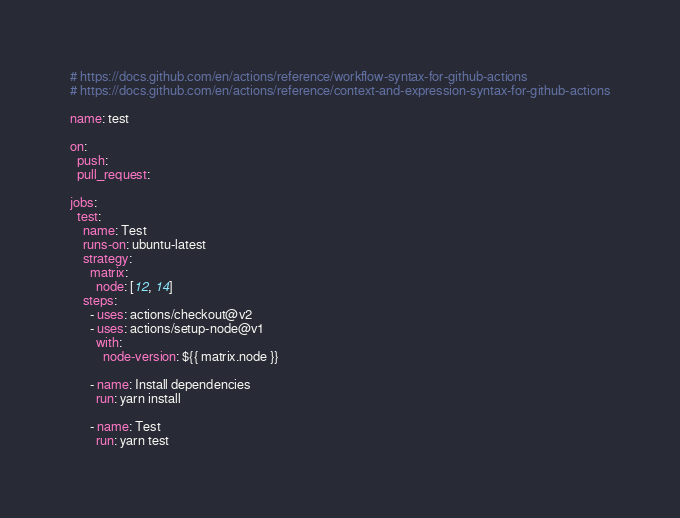Convert code to text. <code><loc_0><loc_0><loc_500><loc_500><_YAML_># https://docs.github.com/en/actions/reference/workflow-syntax-for-github-actions
# https://docs.github.com/en/actions/reference/context-and-expression-syntax-for-github-actions

name: test

on:
  push:
  pull_request:

jobs:
  test:
    name: Test
    runs-on: ubuntu-latest
    strategy:
      matrix:
        node: [12, 14]
    steps:
      - uses: actions/checkout@v2
      - uses: actions/setup-node@v1
        with:
          node-version: ${{ matrix.node }}

      - name: Install dependencies
        run: yarn install

      - name: Test
        run: yarn test
</code> 